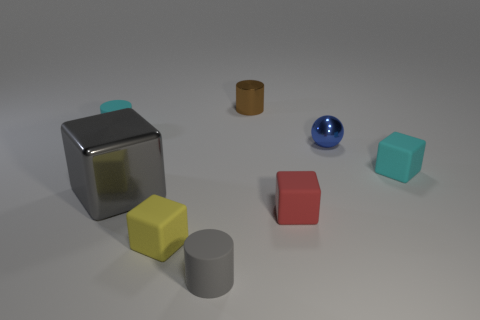Is the number of small metal balls that are in front of the gray matte thing the same as the number of shiny things?
Offer a terse response. No. How many things are tiny cyan things that are to the left of the small yellow rubber object or red objects?
Offer a terse response. 2. Does the matte cube that is on the left side of the small brown cylinder have the same color as the metallic sphere?
Your response must be concise. No. How big is the cyan rubber thing to the right of the blue shiny sphere?
Your response must be concise. Small. What is the shape of the small cyan matte thing that is to the right of the tiny matte cylinder that is behind the cyan block?
Your answer should be very brief. Cube. What is the color of the other large object that is the same shape as the red rubber object?
Offer a terse response. Gray. Does the metallic thing to the left of the brown cylinder have the same size as the small red matte thing?
Make the answer very short. No. What shape is the other rubber object that is the same color as the big object?
Provide a short and direct response. Cylinder. What number of cubes are the same material as the gray cylinder?
Give a very brief answer. 3. There is a cyan object that is right of the tiny shiny cylinder that is behind the small block in front of the red object; what is its material?
Provide a succinct answer. Rubber. 